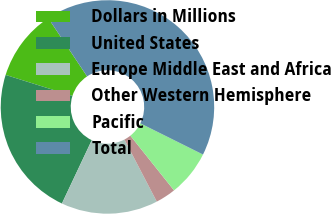Convert chart to OTSL. <chart><loc_0><loc_0><loc_500><loc_500><pie_chart><fcel>Dollars in Millions<fcel>United States<fcel>Europe Middle East and Africa<fcel>Other Western Hemisphere<fcel>Pacific<fcel>Total<nl><fcel>10.79%<fcel>22.84%<fcel>14.66%<fcel>3.07%<fcel>6.93%<fcel>41.71%<nl></chart> 